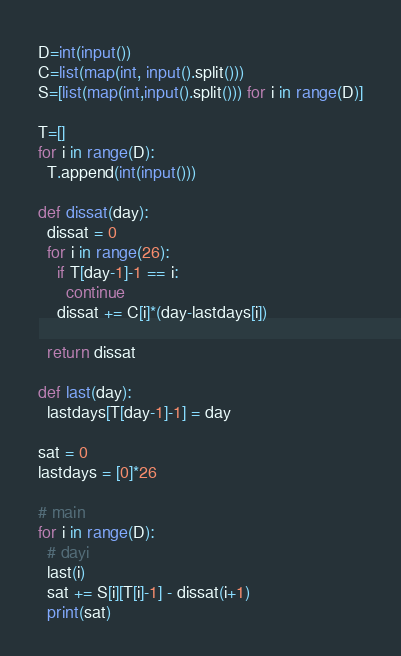Convert code to text. <code><loc_0><loc_0><loc_500><loc_500><_Python_>D=int(input())
C=list(map(int, input().split()))
S=[list(map(int,input().split())) for i in range(D)]

T=[]
for i in range(D):
  T.append(int(input()))

def dissat(day):
  dissat = 0
  for i in range(26):
    if T[day-1]-1 == i:
      continue
    dissat += C[i]*(day-lastdays[i])

  return dissat    
    
def last(day):
  lastdays[T[day-1]-1] = day

sat = 0
lastdays = [0]*26

# main
for i in range(D):
  # dayi
  last(i)
  sat += S[i][T[i]-1] - dissat(i+1)
  print(sat)
</code> 